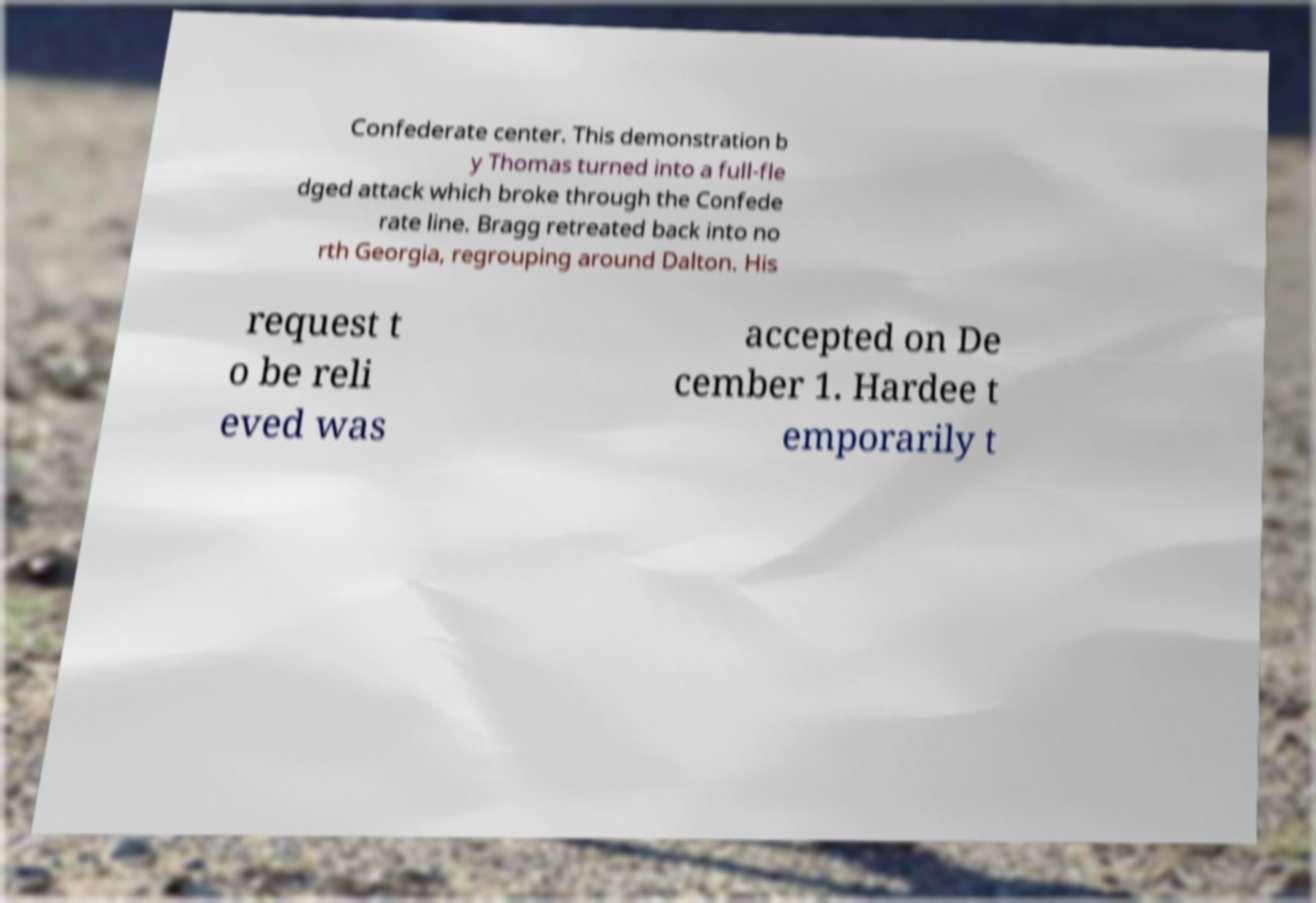Please read and relay the text visible in this image. What does it say? Confederate center. This demonstration b y Thomas turned into a full-fle dged attack which broke through the Confede rate line. Bragg retreated back into no rth Georgia, regrouping around Dalton. His request t o be reli eved was accepted on De cember 1. Hardee t emporarily t 